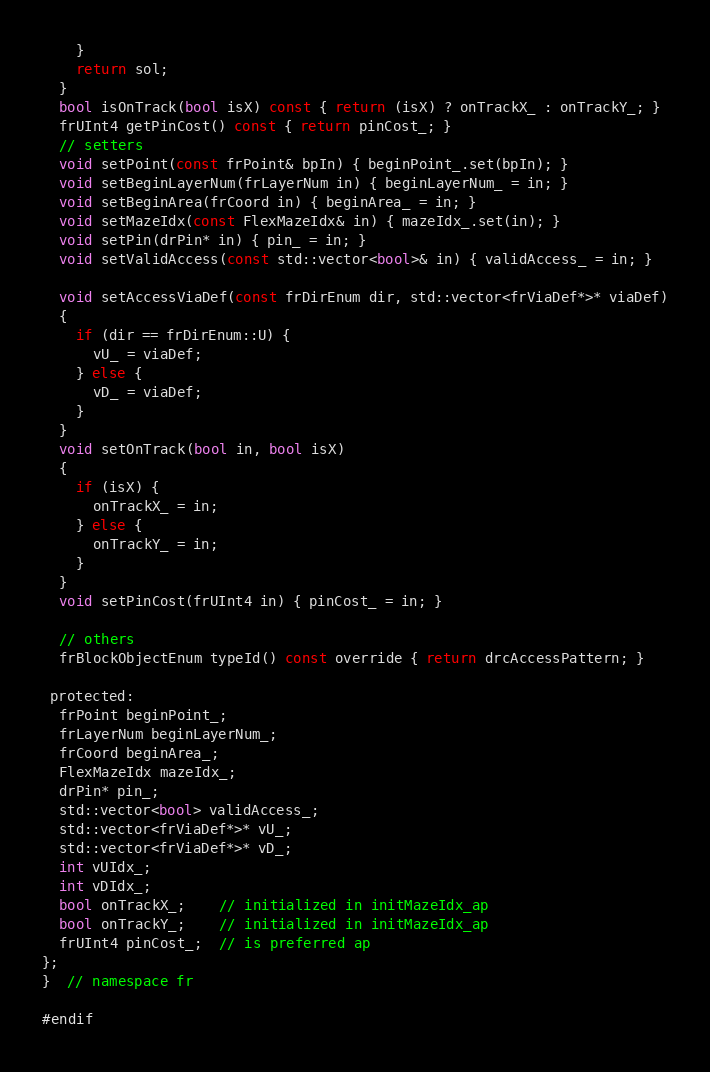Convert code to text. <code><loc_0><loc_0><loc_500><loc_500><_C_>    }
    return sol;
  }
  bool isOnTrack(bool isX) const { return (isX) ? onTrackX_ : onTrackY_; }
  frUInt4 getPinCost() const { return pinCost_; }
  // setters
  void setPoint(const frPoint& bpIn) { beginPoint_.set(bpIn); }
  void setBeginLayerNum(frLayerNum in) { beginLayerNum_ = in; }
  void setBeginArea(frCoord in) { beginArea_ = in; }
  void setMazeIdx(const FlexMazeIdx& in) { mazeIdx_.set(in); }
  void setPin(drPin* in) { pin_ = in; }
  void setValidAccess(const std::vector<bool>& in) { validAccess_ = in; }

  void setAccessViaDef(const frDirEnum dir, std::vector<frViaDef*>* viaDef)
  {
    if (dir == frDirEnum::U) {
      vU_ = viaDef;
    } else {
      vD_ = viaDef;
    }
  }
  void setOnTrack(bool in, bool isX)
  {
    if (isX) {
      onTrackX_ = in;
    } else {
      onTrackY_ = in;
    }
  }
  void setPinCost(frUInt4 in) { pinCost_ = in; }

  // others
  frBlockObjectEnum typeId() const override { return drcAccessPattern; }

 protected:
  frPoint beginPoint_;
  frLayerNum beginLayerNum_;
  frCoord beginArea_;
  FlexMazeIdx mazeIdx_;
  drPin* pin_;
  std::vector<bool> validAccess_;
  std::vector<frViaDef*>* vU_;
  std::vector<frViaDef*>* vD_;
  int vUIdx_;
  int vDIdx_;
  bool onTrackX_;    // initialized in initMazeIdx_ap
  bool onTrackY_;    // initialized in initMazeIdx_ap
  frUInt4 pinCost_;  // is preferred ap
};
}  // namespace fr

#endif
</code> 